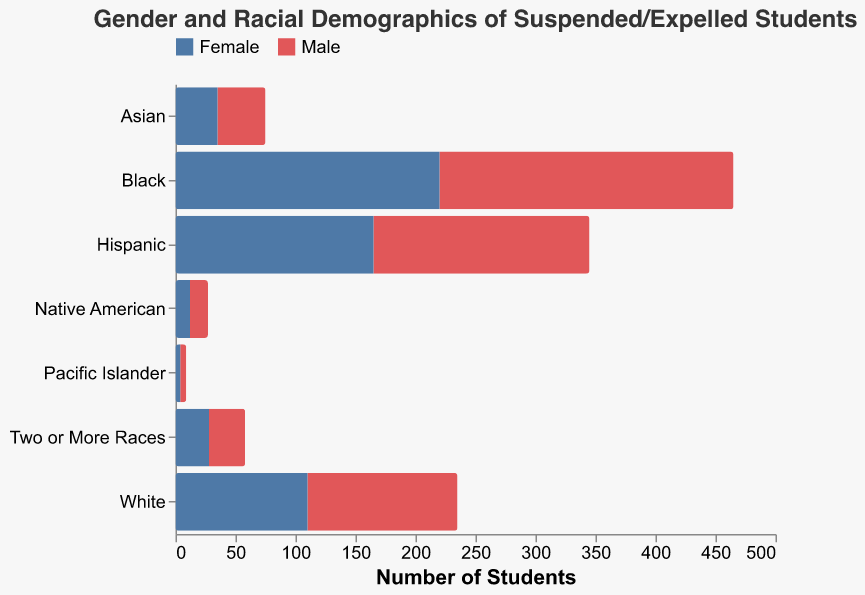Which racial category has the highest number of suspended or expelled male students? Look at the bars representing male students (left-hand side). The Black category has the longest bar (245 students).
Answer: Black Which racial category has the highest number of suspended or expelled female students? Look at the bars representing female students (right-hand side). The Black category has the longest bar (220 students).
Answer: Black How many more Black male students are suspended or expelled compared to White male students? Compare the values for Black and White male students: 245 (Black) - 125 (White) = 120 more Black male students.
Answer: 120 more Which gender has more suspensions or expulsions among Hispanic students? Compare the lengths of the bars for Hispanic Male and Hispanic Female. The Male bar is longer (180) compared to Female (165).
Answer: Male What is the total number of suspended or expelled Native American students? Sum the values for Native American male and female: 15 (male) + 12 (female) = 27 students.
Answer: 27 Among Asian students, which gender category has fewer suspensions or expulsions? Compare the lengths of the bars for Asian Male and Asian Female. The Female bar is slightly shorter (35) than the Male bar (40).
Answer: Female How many more suspended or expelled students are there in the Two or More Races category compared to the Pacific Islander category? Sum the values of both genders for Two or More Races and Pacific Islander: (30 + 28) - (5 + 4) = 58 - 9 = 49 more students.
Answer: 49 Which category has the closest number of suspended or expelled students between genders? Compare the differences for each category: White (15), Black (25), Hispanic (15), Asian (5), Native American (3), Pacific Islander (1), Two or More Races (2). The Pacific Islander category has the smallest difference between genders (1).
Answer: Pacific Islander What is the overall ratio of suspended or expelled females to males across all categories? First sum up the total for each gender: Female (110 + 220 + 165 + 35 + 12 + 4 + 28 = 574), Male (125 + 245 + 180 + 40 + 15 + 5 + 30 = 640). Then calculate the ratio: 574/640 ≈ 0.896.
Answer: Approximately 0.896 